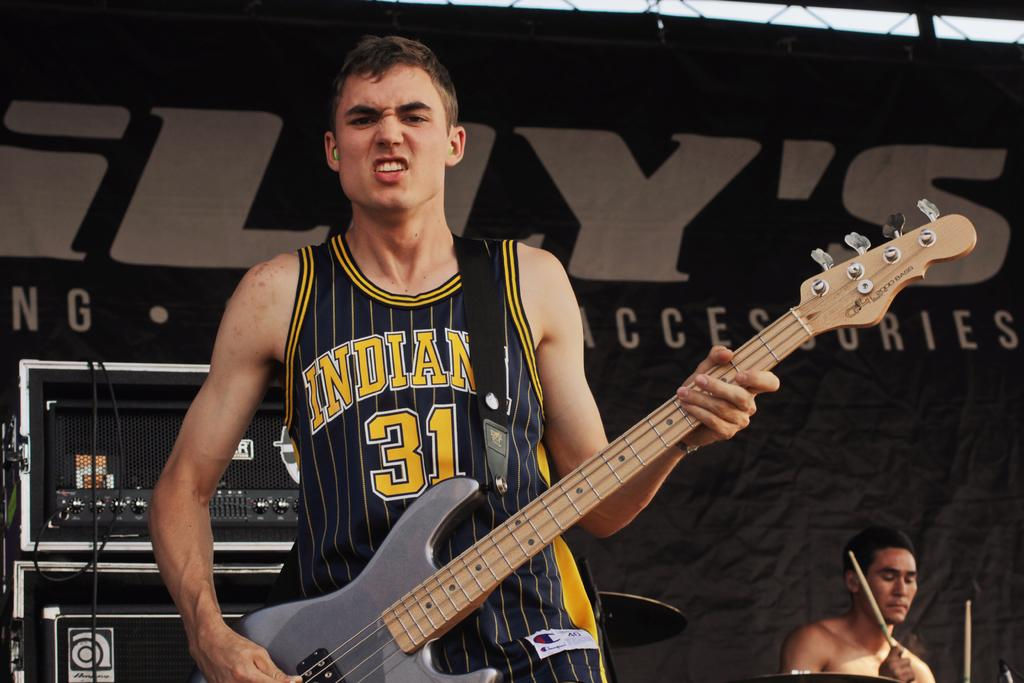<image>
Relay a brief, clear account of the picture shown. Number 31 of Indiana is shown on the tank top of the guitar player. 